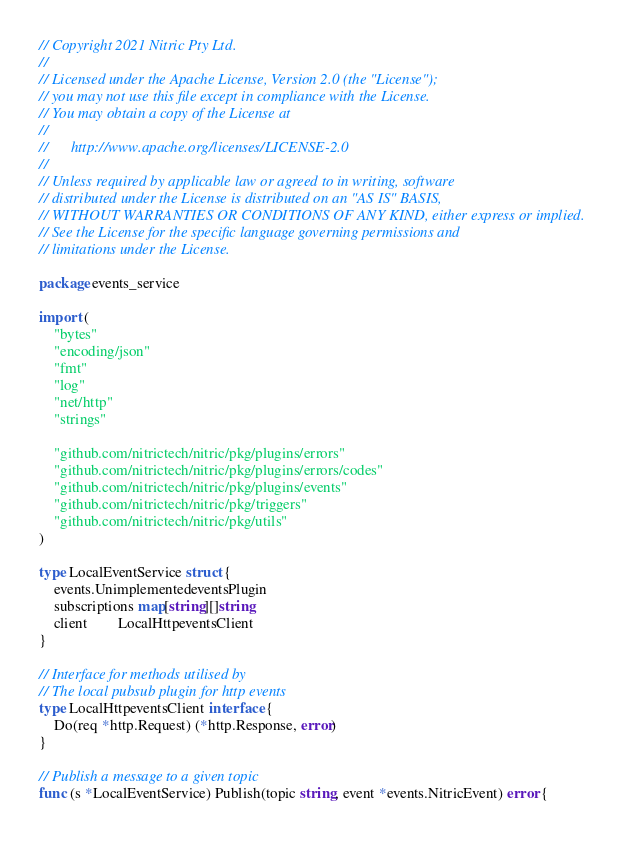<code> <loc_0><loc_0><loc_500><loc_500><_Go_>// Copyright 2021 Nitric Pty Ltd.
//
// Licensed under the Apache License, Version 2.0 (the "License");
// you may not use this file except in compliance with the License.
// You may obtain a copy of the License at
//
//      http://www.apache.org/licenses/LICENSE-2.0
//
// Unless required by applicable law or agreed to in writing, software
// distributed under the License is distributed on an "AS IS" BASIS,
// WITHOUT WARRANTIES OR CONDITIONS OF ANY KIND, either express or implied.
// See the License for the specific language governing permissions and
// limitations under the License.

package events_service

import (
	"bytes"
	"encoding/json"
	"fmt"
	"log"
	"net/http"
	"strings"

	"github.com/nitrictech/nitric/pkg/plugins/errors"
	"github.com/nitrictech/nitric/pkg/plugins/errors/codes"
	"github.com/nitrictech/nitric/pkg/plugins/events"
	"github.com/nitrictech/nitric/pkg/triggers"
	"github.com/nitrictech/nitric/pkg/utils"
)

type LocalEventService struct {
	events.UnimplementedeventsPlugin
	subscriptions map[string][]string
	client        LocalHttpeventsClient
}

// Interface for methods utilised by
// The local pubsub plugin for http events
type LocalHttpeventsClient interface {
	Do(req *http.Request) (*http.Response, error)
}

// Publish a message to a given topic
func (s *LocalEventService) Publish(topic string, event *events.NitricEvent) error {</code> 